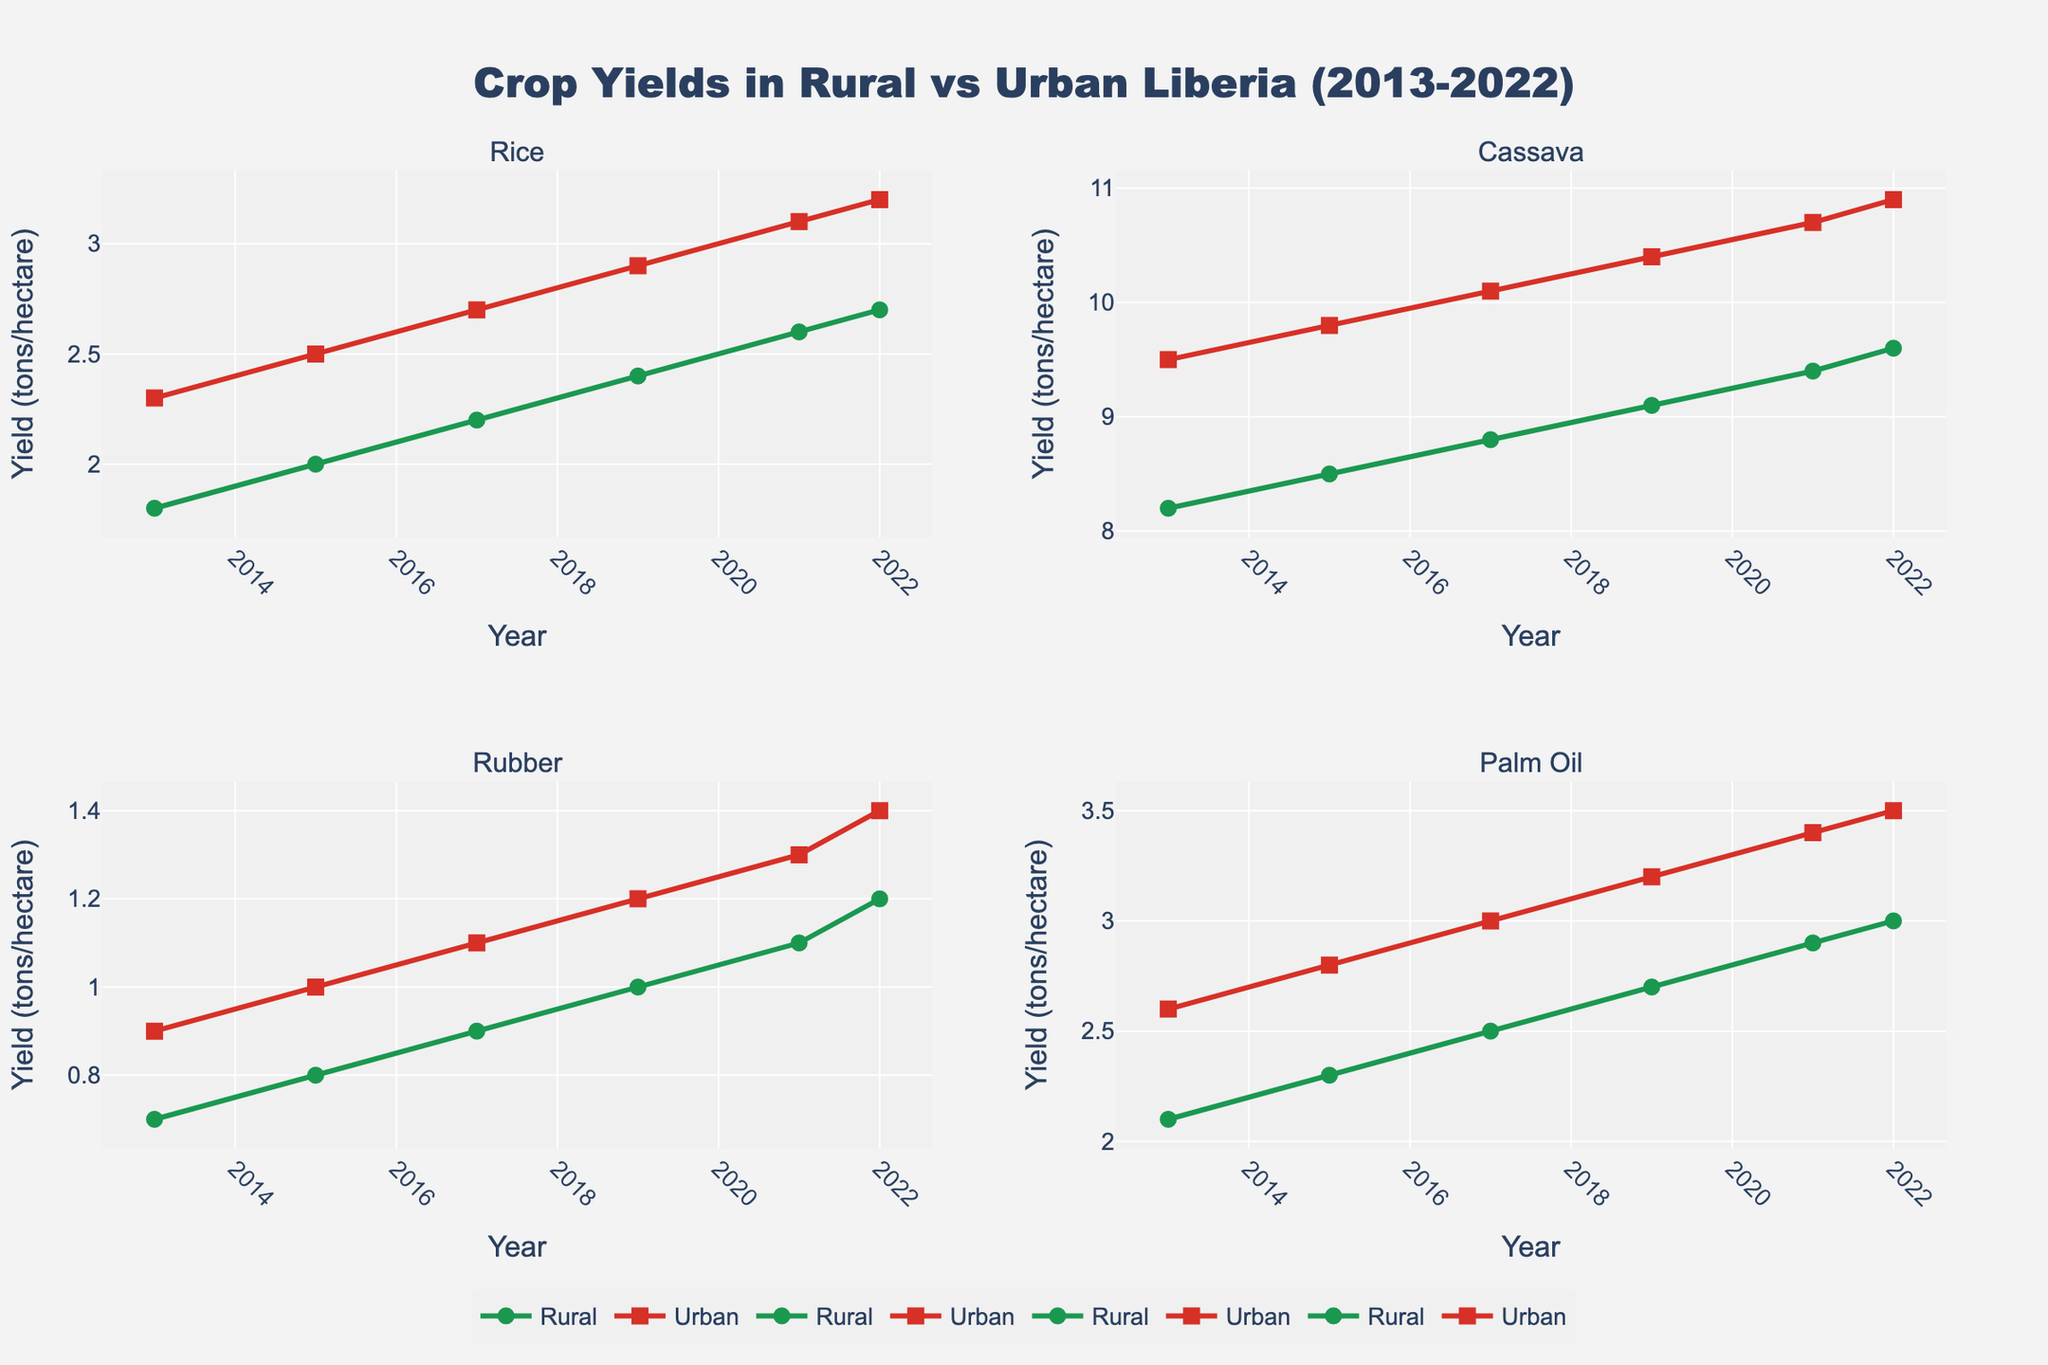What crops are shown in the figure? The figure consists of subplots, each titled with a different crop. The titles of the subplots reveal the crops that are shown.
Answer: Rice, Cassava, Rubber, Palm Oil What is the yield for Rice in rural areas in 2017? To find this, look at the data points on the line representing rural yields for Rice in the subplot titled "Rice" during the year 2017.
Answer: 2.2 tons/hectare How did the urban yield for Rubber change from 2013 to 2022? Observe the Rubber subplot and track the data points for urban yield from 2013 to 2022. The yields increased over time.
Answer: It increased from 0.9 to 1.4 tons/hectare Compare the rural yields of Cassava in 2013 and 2017. Look at the subplot for Cassava, and compare the data points of rural yields for the years 2013 and 2017.
Answer: Increase from 8.2 to 8.8 tons/hectare In which year did the urban yield of Palm Oil exceed the rural yield by the greatest amount? Examine the Palm Oil subplot and compare the differences between urban and rural yields for each year. Calculate the differences and find the maximum.
Answer: 2022 Which crop displayed the smallest difference in urban and rural yields in 2019? For each crop subplot, find the difference between urban and rural yields for the data points in 2019. Determine the smallest value among them.
Answer: Rubber On average, how much did the rural yield of Rice increase per year from 2013 to 2022? Subtract the 2013 rural yield of Rice from the 2022 rural yield and divide by the number of years (2022-2013=9).
Answer: 0.1 tons/hectare per year Which crop had the highest rural yield in 2021? Identify the rural yield data points for each crop in the subplots for the year 2021 and determine the highest yield.
Answer: Cassava Does the data show any crop where the rural yield was higher than the urban yield in any year? Examine all subplots for any instance where the data point for rural yield is higher than urban yield for any year.
Answer: No, urban yields were always higher What is the trend in urban yields for Cassava from 2013 to 2022? Observe the line representing urban yields for Cassava in the corresponding subplot and describe the directional trend over the years.
Answer: Increasing trend 